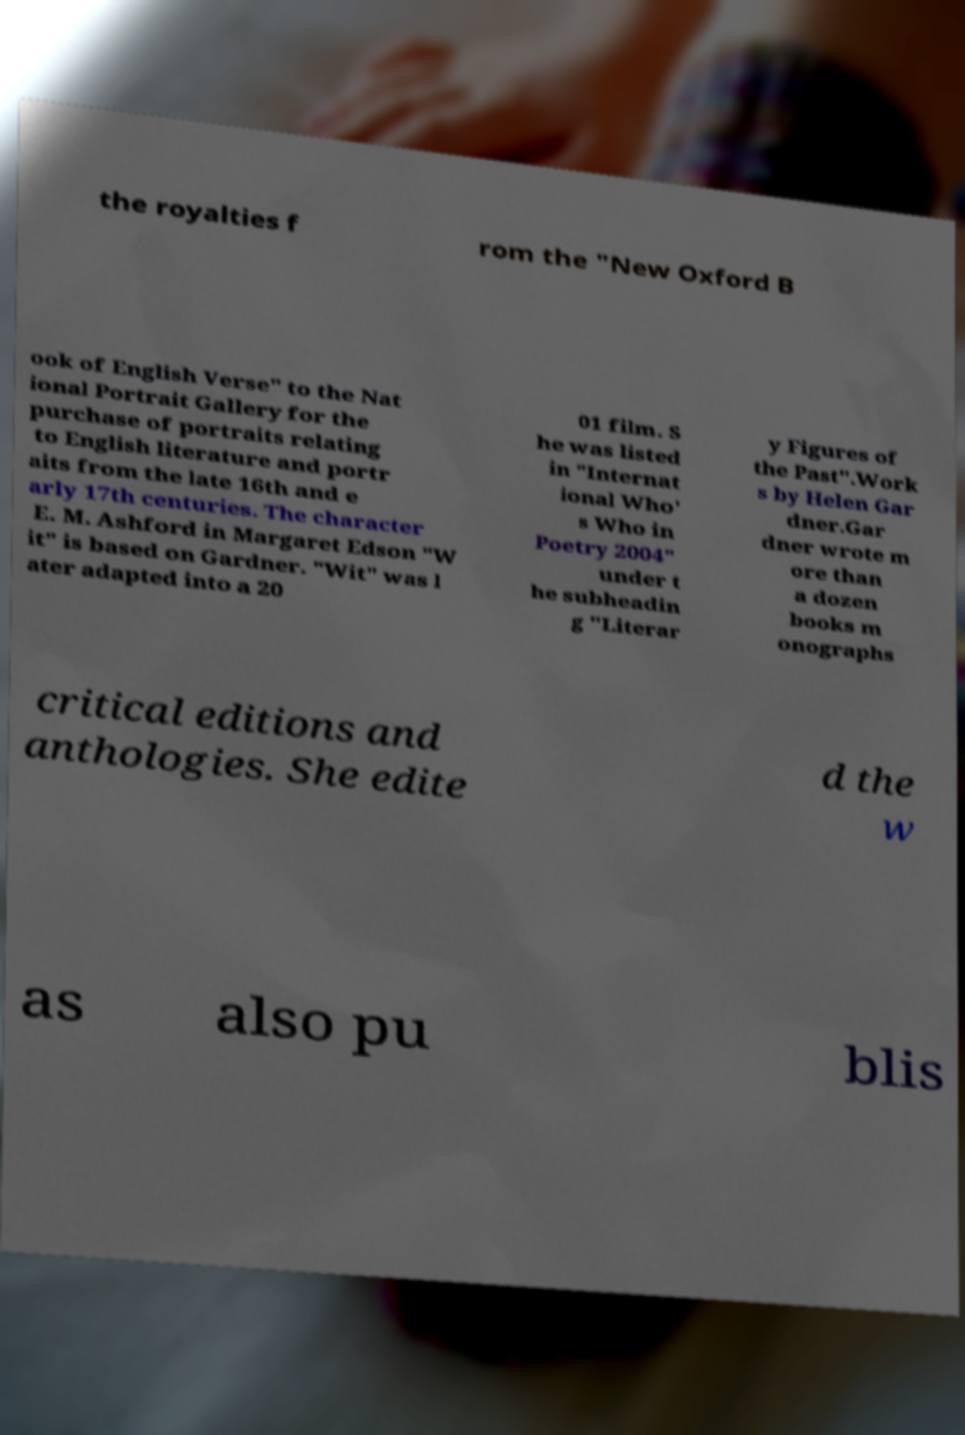What messages or text are displayed in this image? I need them in a readable, typed format. the royalties f rom the "New Oxford B ook of English Verse" to the Nat ional Portrait Gallery for the purchase of portraits relating to English literature and portr aits from the late 16th and e arly 17th centuries. The character E. M. Ashford in Margaret Edson "W it" is based on Gardner. "Wit" was l ater adapted into a 20 01 film. S he was listed in "Internat ional Who' s Who in Poetry 2004" under t he subheadin g "Literar y Figures of the Past".Work s by Helen Gar dner.Gar dner wrote m ore than a dozen books m onographs critical editions and anthologies. She edite d the w as also pu blis 